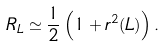<formula> <loc_0><loc_0><loc_500><loc_500>R _ { L } \simeq \frac { 1 } { 2 } \left ( 1 + r ^ { 2 } ( L ) \right ) .</formula> 